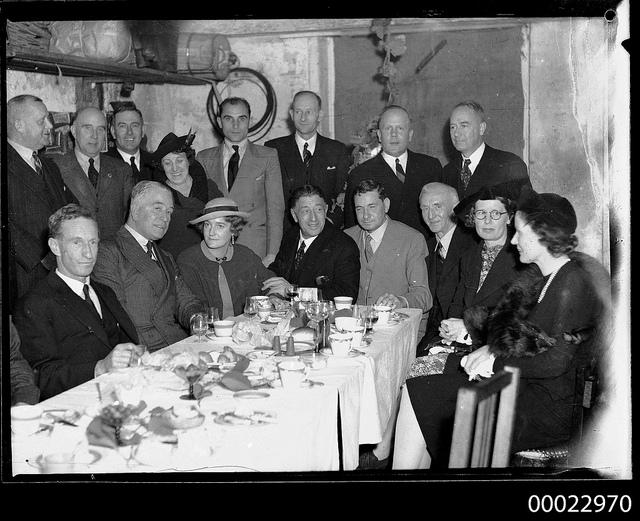Is this photo in color or black and white?
Keep it brief. Black and white. Are the people at the top real?
Write a very short answer. Yes. Does the couple appear to be young?
Keep it brief. No. What are the numbers on the photo?
Answer briefly. 00022970. Is the same little girl in the photos?
Answer briefly. No. Are the people looking at?
Be succinct. Camera. Is anyone sitting in the chair?
Give a very brief answer. Yes. Is the image in black and white?
Concise answer only. Yes. Where was this shot at?
Give a very brief answer. Dinner. What this photo taken in 2015?
Concise answer only. No. Are there pineapples on the table?
Keep it brief. No. What celebration are these people enjoying?
Concise answer only. Birthday. How many people are here?
Give a very brief answer. 16. 